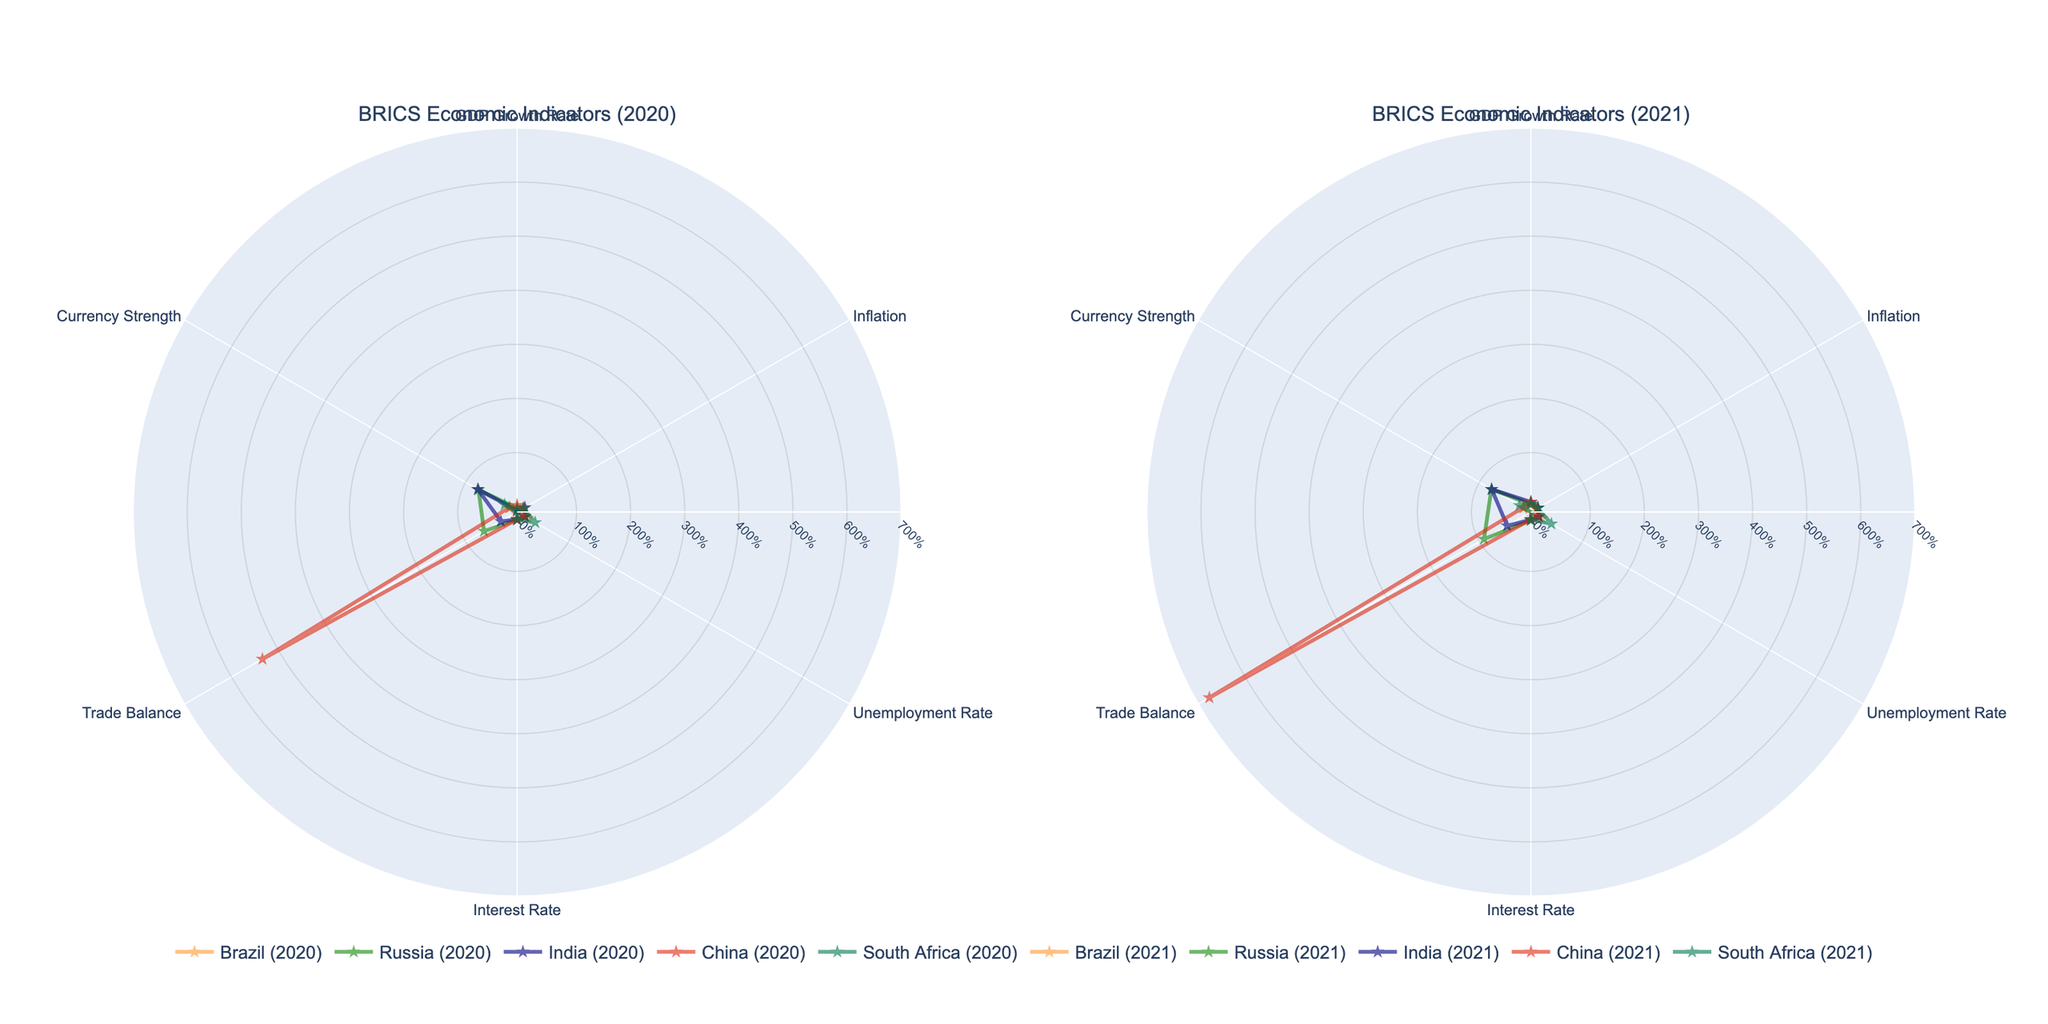Which BRICS nation had the highest GDP growth rate in 2021? Look at the subplot titled "BRICS Economic Indicators (2021)" and compare the GDP growth rates of all nations. The highest value is China with 8.1%.
Answer: China Which two countries had negative GDP growth rates in 2020? Look at the subplot titled "BRICS Economic Indicators (2020)" and identify the countries with negative values for the GDP growth rate. Brazil (-4.1%) and South Africa (-6.4%) both have negative values.
Answer: Brazil and South Africa How did India’s unemployment rate change from 2020 to 2021? Compare India’s unemployment rate between the 2020 and 2021 subplots. The rate rose from 7.1% in 2020 to 7.5% in 2021.
Answer: Increased by 0.4% Which country exhibited the highest inflation rate in 2021 among the BRICS nations? Check the inflation rates in the 2021 subplot for all BRICS nations. The highest inflation rate is seen in Russia at 4.9%.
Answer: Russia What is the change in China's trade balance from 2020 to 2021? Look at China's trade balance values in both subplots. It increased from 533.76 in 2020 to 676.43 in 2021. The change is 676.43 - 533.76 = 142.67
Answer: Increased by 142.67 Compare Russia and Brazil’s interest rates in 2021. Which country had a higher interest rate? Refer to the subplot for 2021 and examine the interest rates for Russia and Brazil. Russia had 5.5%, whereas Brazil had 4.25%.
Answer: Russia Which country showed an improvement in GDP growth rate from 2020 to 2021? Look for countries where the GDP growth rate increased from 2020 to 2021 in their respective subplots. Brazil, Russia, India, China, and South Africa all showed improvements.
Answer: Brazil, Russia, India, China, South Africa What was the unemployment rate in South Africa in 2020, and how did it change by 2021? Identify the unemployment rate for South Africa in the subplots for both years. It was 28.7% in 2020 and increased to 33.8% in 2021.
Answer: Increased by 5.1% Which country had the strongest currency in 2020 according to the radar charts? Check the currency strength values for all countries in the 2020 subplot. China's currency strength is 6.52, the lowest value indicating the strongest currency.
Answer: China Compare the trade balance of BRICS nations in 2020. Which country had the most significant trade balance deficit? Look at the trade balance values for all countries in the 2020 subplot. Brazil had the most significant deficit at -32.16.
Answer: Brazil 